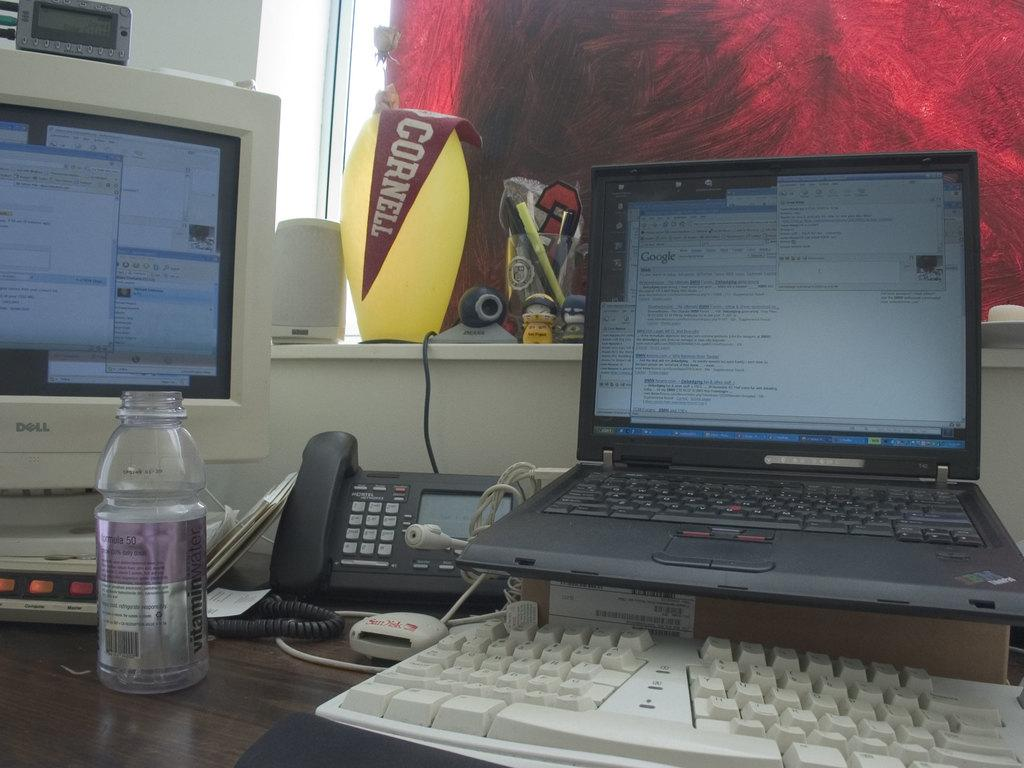<image>
Share a concise interpretation of the image provided. A white, Dell desktop computer sitting to the left of an opened black laptop on a desk. 